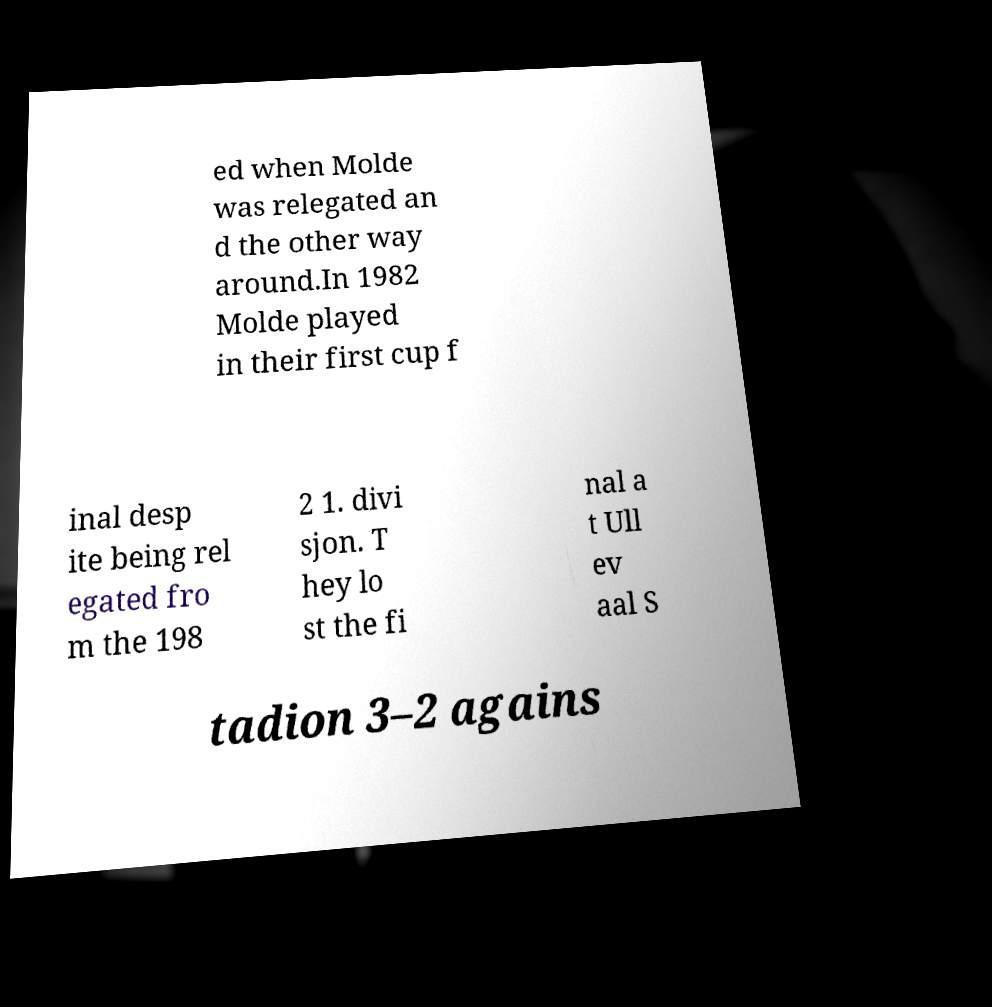For documentation purposes, I need the text within this image transcribed. Could you provide that? ed when Molde was relegated an d the other way around.In 1982 Molde played in their first cup f inal desp ite being rel egated fro m the 198 2 1. divi sjon. T hey lo st the fi nal a t Ull ev aal S tadion 3–2 agains 